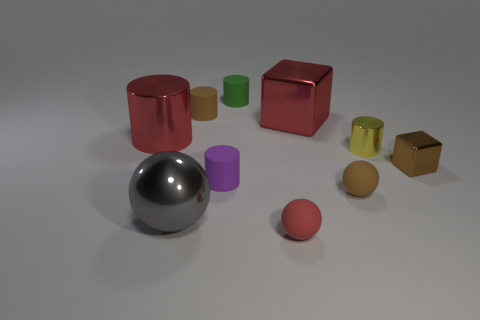Subtract all brown cylinders. How many cylinders are left? 4 Subtract all yellow cylinders. How many cylinders are left? 4 Subtract all gray cylinders. Subtract all gray blocks. How many cylinders are left? 5 Subtract all blocks. How many objects are left? 8 Subtract 1 green cylinders. How many objects are left? 9 Subtract all small matte blocks. Subtract all tiny brown metallic blocks. How many objects are left? 9 Add 3 brown cubes. How many brown cubes are left? 4 Add 7 blocks. How many blocks exist? 9 